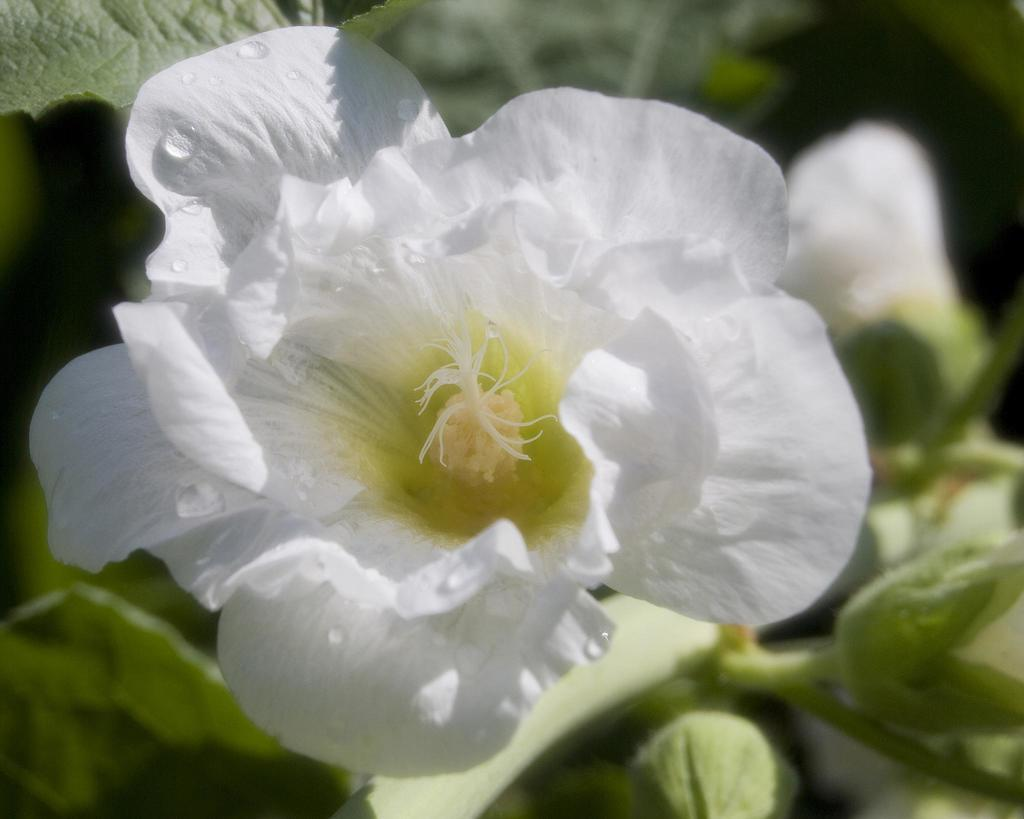What color are the flowers in the image? The flowers in the image are white. Can you describe the appearance of the flowers? The petals of the flowers have water droplets on them. What can be seen in the background of the image? There are plants in the background of the image. What type of punishment is being administered in the alley in the image? There is no alley or punishment present in the image; it features white flowers with water droplets on their petals and plants in the background. 